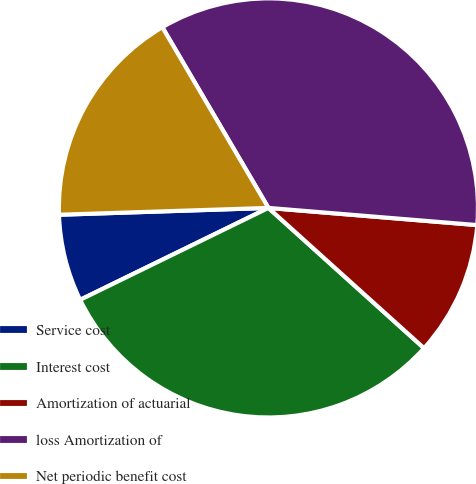Convert chart. <chart><loc_0><loc_0><loc_500><loc_500><pie_chart><fcel>Service cost<fcel>Interest cost<fcel>Amortization of actuarial<fcel>loss Amortization of<fcel>Net periodic benefit cost<nl><fcel>6.71%<fcel>31.1%<fcel>10.37%<fcel>34.76%<fcel>17.07%<nl></chart> 